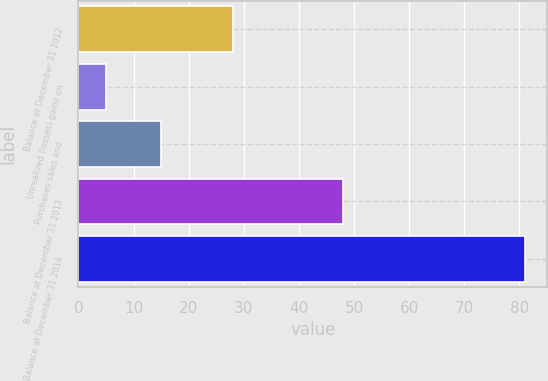Convert chart. <chart><loc_0><loc_0><loc_500><loc_500><bar_chart><fcel>Balance at December 31 2012<fcel>Unrealized (losses) gains on<fcel>Purchases sales and<fcel>Balance at December 31 2013<fcel>Balance at December 31 2014<nl><fcel>28<fcel>5<fcel>15<fcel>48<fcel>81<nl></chart> 